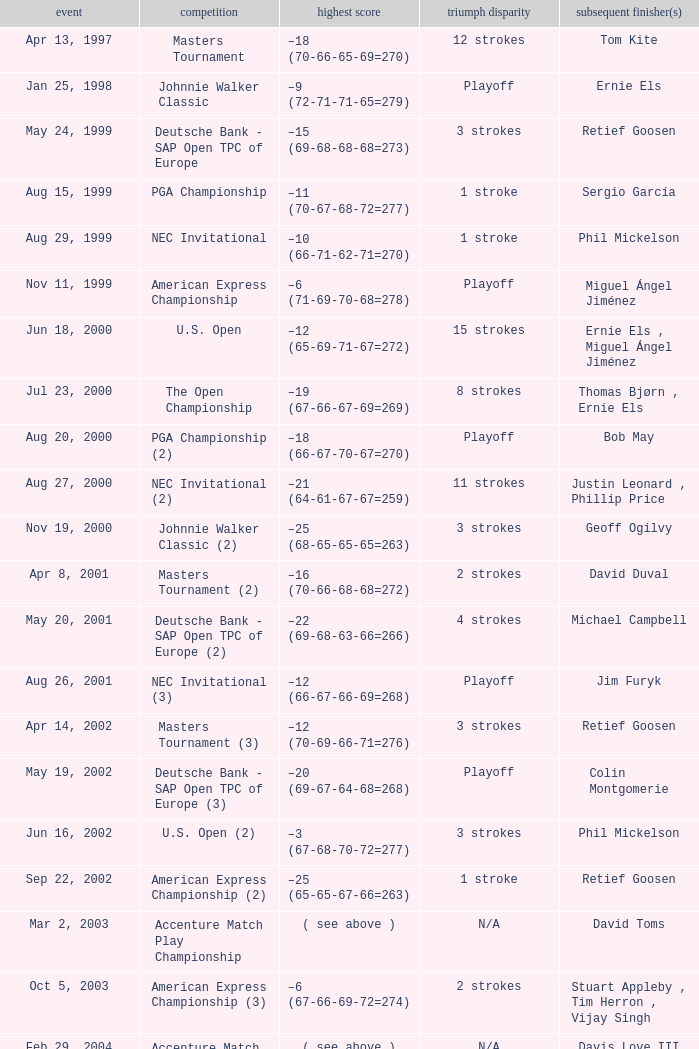Who has the Winning score of –10 (66-71-62-71=270) ? Phil Mickelson. 